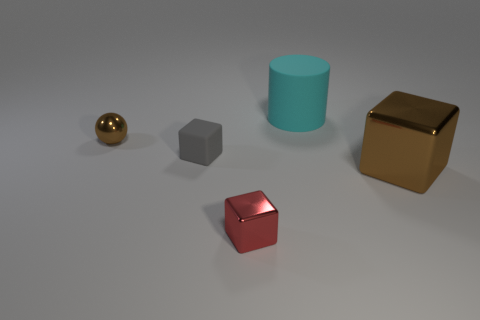Subtract all red cubes. How many cubes are left? 2 Subtract 2 cubes. How many cubes are left? 1 Add 2 blocks. How many objects exist? 7 Subtract all brown blocks. How many blocks are left? 2 Subtract all balls. How many objects are left? 4 Add 1 small gray cubes. How many small gray cubes are left? 2 Add 5 large blue rubber spheres. How many large blue rubber spheres exist? 5 Subtract 1 brown spheres. How many objects are left? 4 Subtract all gray spheres. Subtract all blue blocks. How many spheres are left? 1 Subtract all blue spheres. How many red cylinders are left? 0 